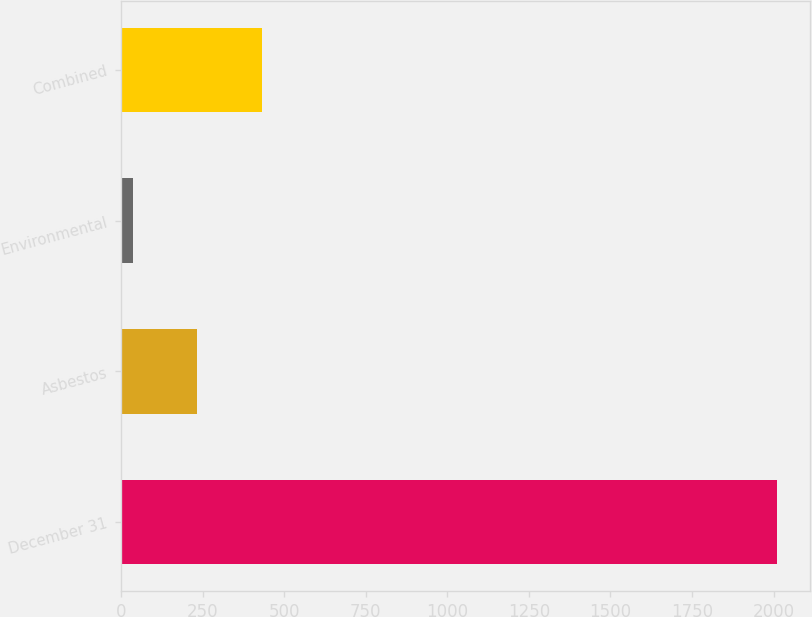<chart> <loc_0><loc_0><loc_500><loc_500><bar_chart><fcel>December 31<fcel>Asbestos<fcel>Environmental<fcel>Combined<nl><fcel>2012<fcel>232.7<fcel>35<fcel>430.4<nl></chart> 